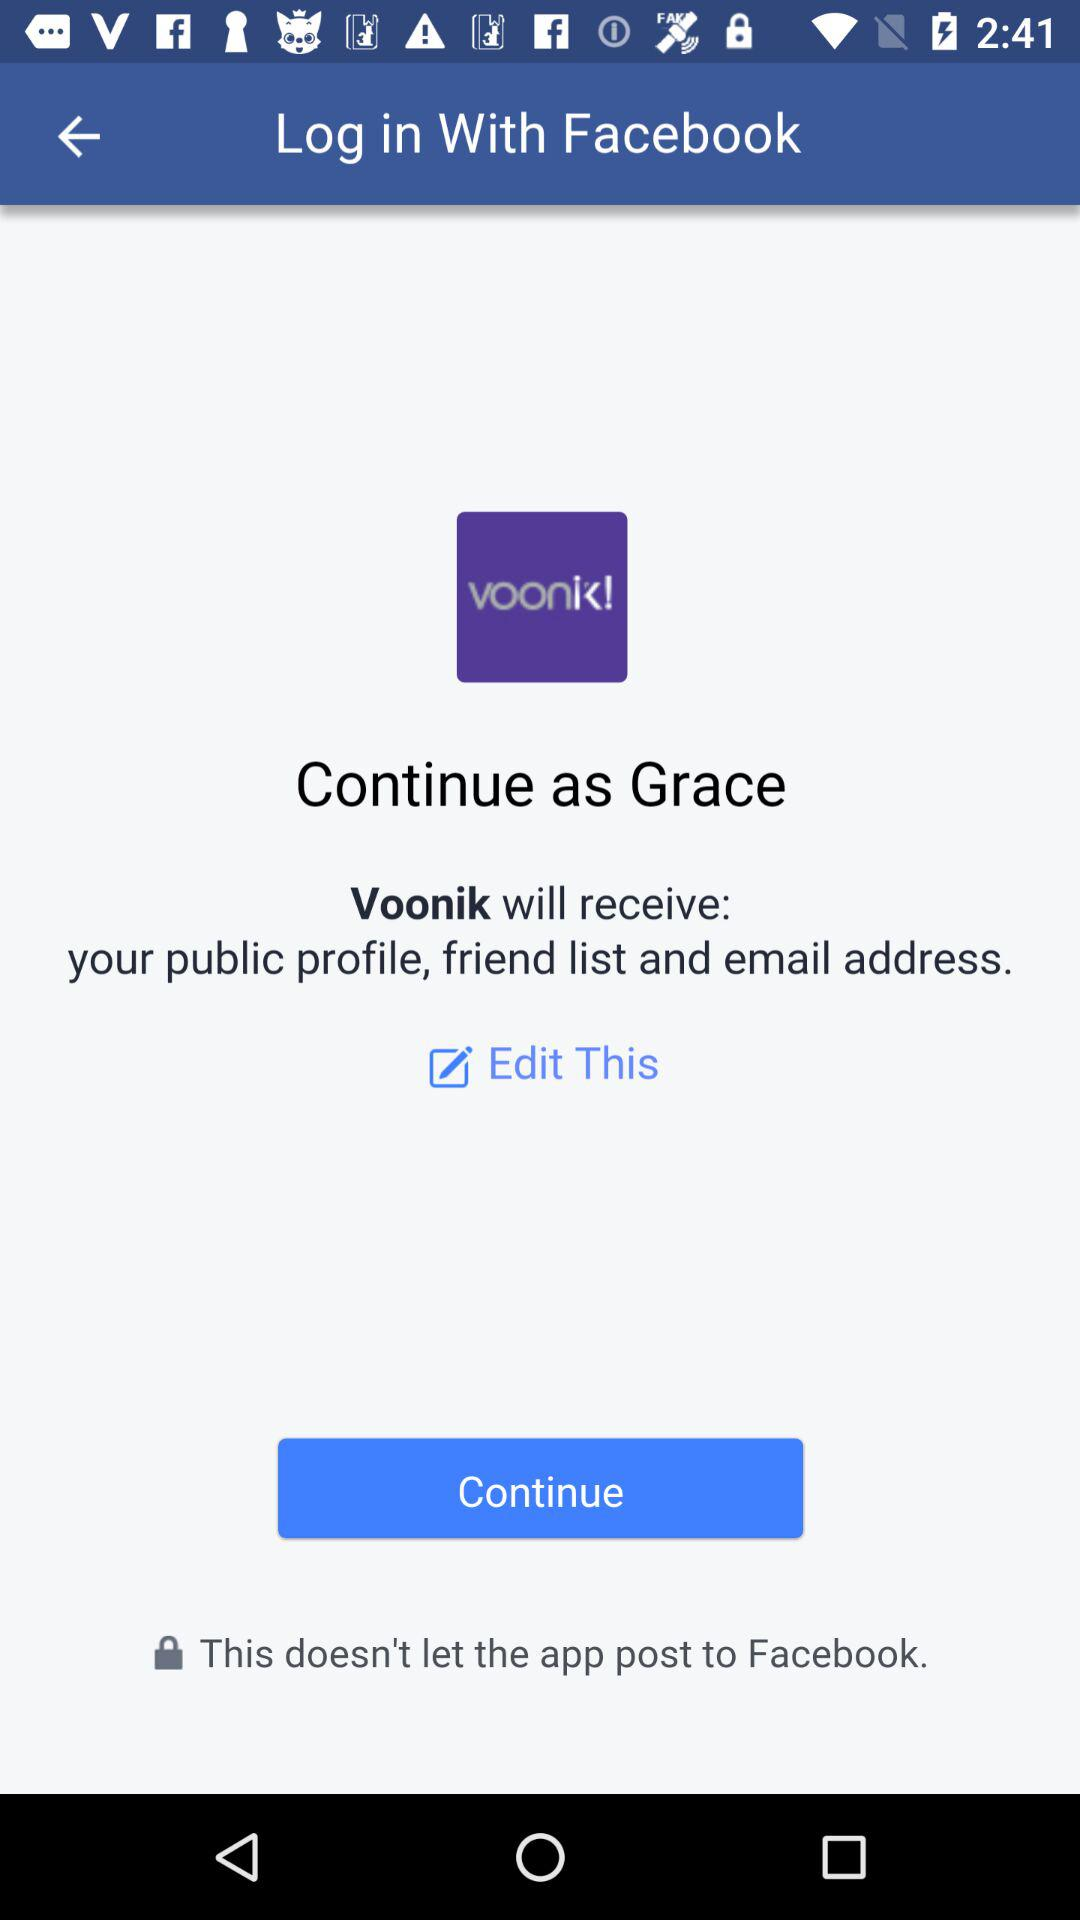What is the user name? The user name is Grace. 